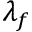<formula> <loc_0><loc_0><loc_500><loc_500>\lambda _ { f }</formula> 